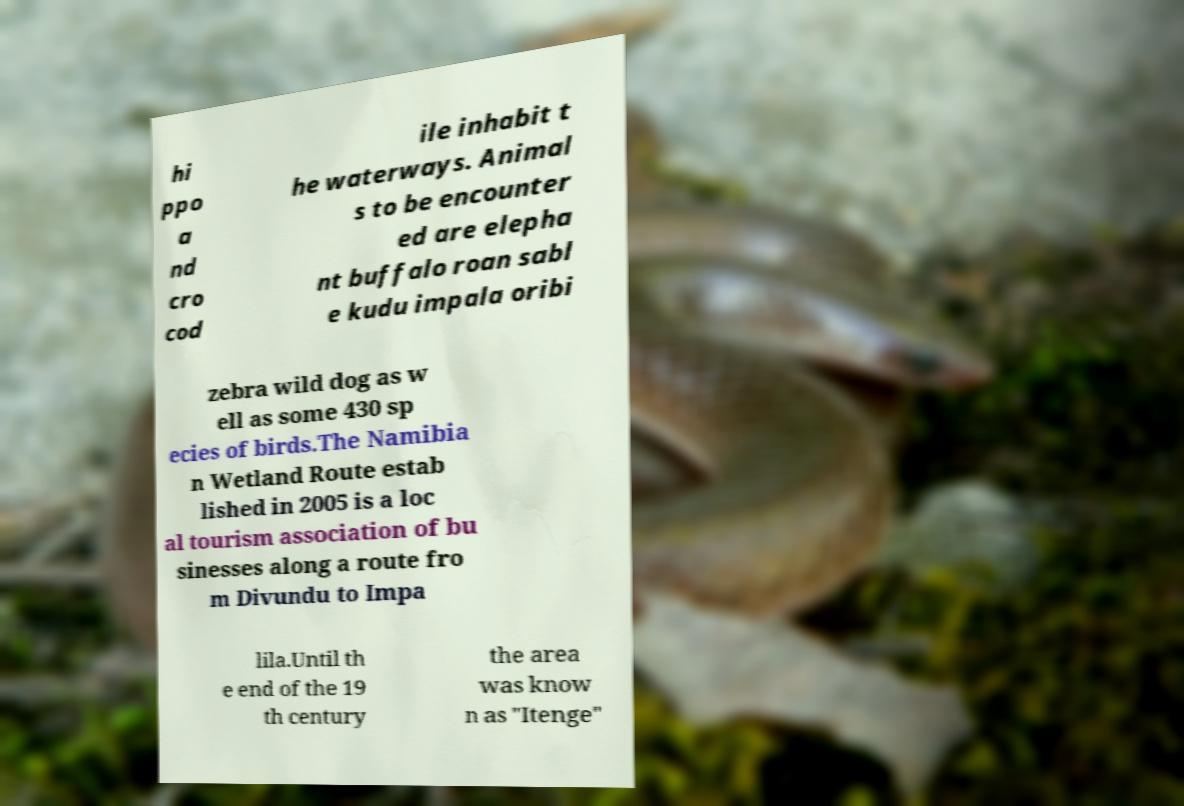Please identify and transcribe the text found in this image. hi ppo a nd cro cod ile inhabit t he waterways. Animal s to be encounter ed are elepha nt buffalo roan sabl e kudu impala oribi zebra wild dog as w ell as some 430 sp ecies of birds.The Namibia n Wetland Route estab lished in 2005 is a loc al tourism association of bu sinesses along a route fro m Divundu to Impa lila.Until th e end of the 19 th century the area was know n as "Itenge" 